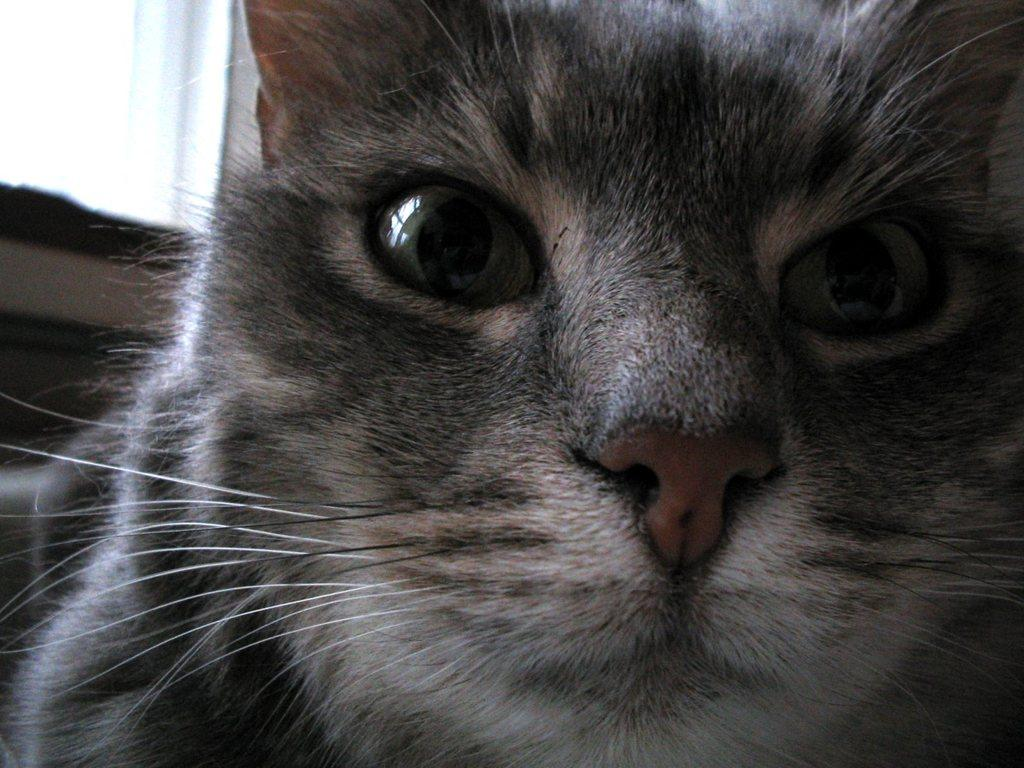What animal is in the front of the image? There is a cat in the front of the image. What can be seen in the background of the image? There is an object in the background of the image. What is the color of the object in the background? The object is black in color. What type of sweater is the cat wearing in the image? There is no sweater present in the image, and the cat is not wearing any clothing. 